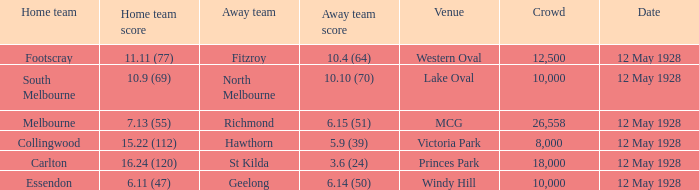Who is the away side when the crowd is over 18,000 with collingwood at home? None. 